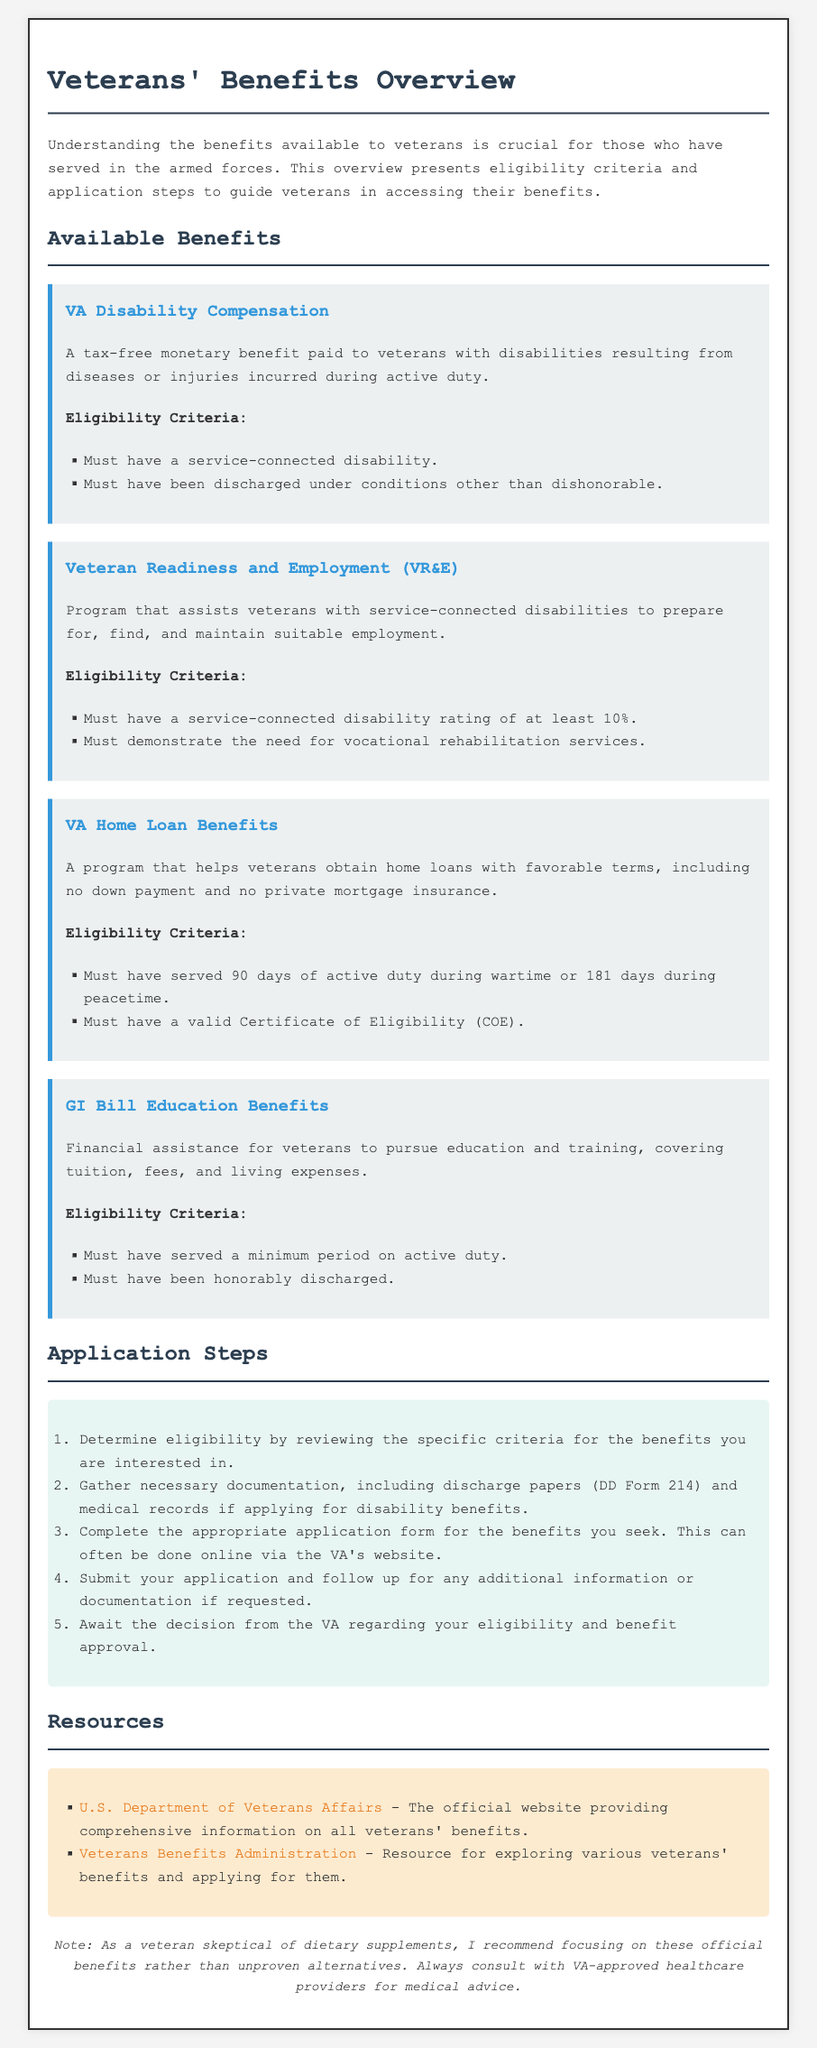what is VA Disability Compensation? VA Disability Compensation is a tax-free monetary benefit paid to veterans with disabilities resulting from diseases or injuries incurred during active duty.
Answer: tax-free monetary benefit what is one eligibility requirement for the GI Bill Education Benefits? One eligibility requirement for the GI Bill Education Benefits is that the veteran must have served a minimum period on active duty.
Answer: served a minimum period on active duty how long must a veteran have served during wartime to qualify for VA Home Loan Benefits? A veteran must have served 90 days of active duty during wartime to qualify for VA Home Loan Benefits.
Answer: 90 days what is the first step in the application process for veterans' benefits? The first step is to determine eligibility by reviewing the specific criteria for the benefits you are interested in.
Answer: determine eligibility how much disability rating is needed for Veteran Readiness and Employment? A disability rating of at least 10% is required for Veteran Readiness and Employment.
Answer: at least 10% which department provides comprehensive information on all veterans' benefits? The U.S. Department of Veterans Affairs provides comprehensive information on all veterans' benefits.
Answer: U.S. Department of Veterans Affairs what is the primary purpose of the GI Bill Education Benefits? The primary purpose is to provide financial assistance for veterans to pursue education and training, covering tuition, fees, and living expenses.
Answer: financial assistance for education and training what document is often required when applying for disability benefits? Discharge papers (DD Form 214) are often required when applying for disability benefits.
Answer: Discharge papers (DD Form 214) 